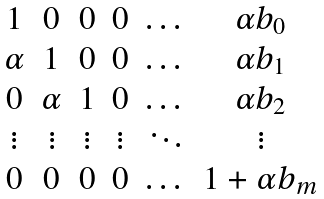Convert formula to latex. <formula><loc_0><loc_0><loc_500><loc_500>\begin{matrix} 1 & 0 & 0 & 0 & \dots & \alpha b _ { 0 } \\ \alpha & 1 & 0 & 0 & \dots & \alpha b _ { 1 } \\ 0 & \alpha & 1 & 0 & \dots & \alpha b _ { 2 } \\ \vdots & \vdots & \vdots & \vdots & \ddots & \vdots \\ 0 & 0 & 0 & 0 & \dots & 1 + \alpha b _ { m } \end{matrix}</formula> 